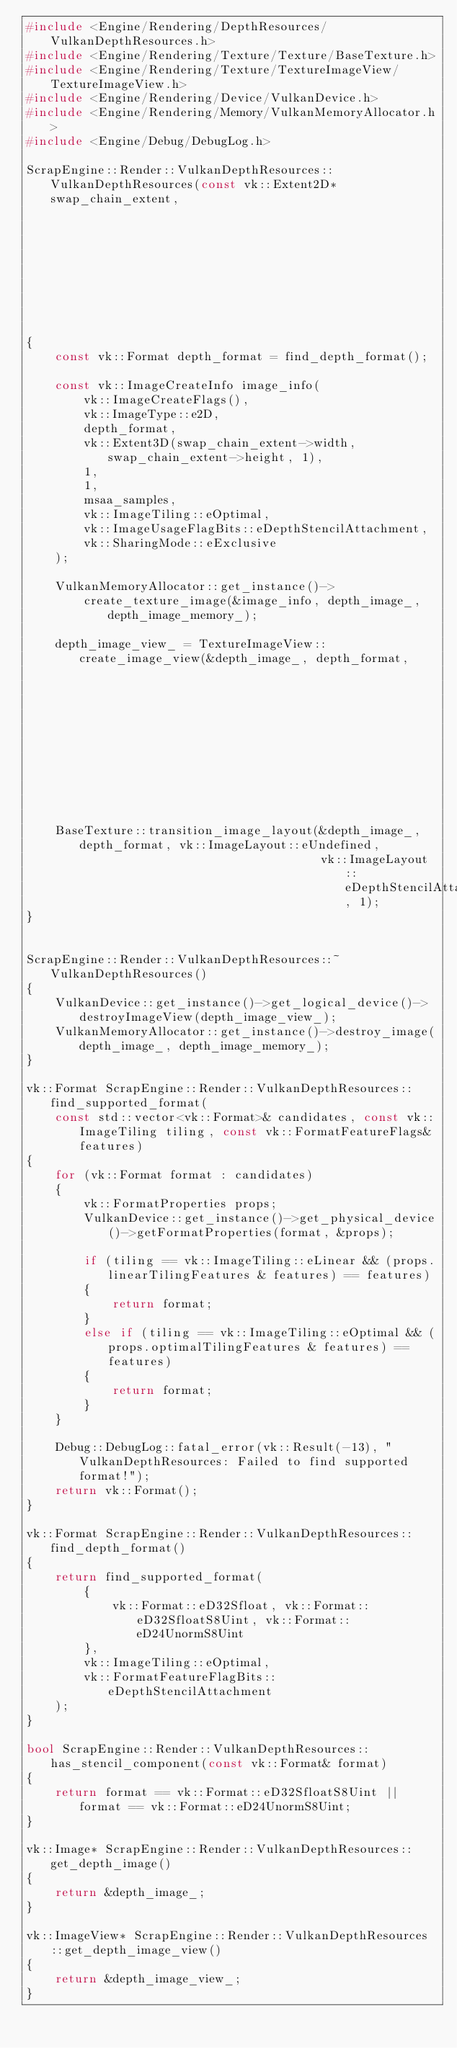Convert code to text. <code><loc_0><loc_0><loc_500><loc_500><_C++_>#include <Engine/Rendering/DepthResources/VulkanDepthResources.h>
#include <Engine/Rendering/Texture/Texture/BaseTexture.h>
#include <Engine/Rendering/Texture/TextureImageView/TextureImageView.h>
#include <Engine/Rendering/Device/VulkanDevice.h>
#include <Engine/Rendering/Memory/VulkanMemoryAllocator.h>
#include <Engine/Debug/DebugLog.h>

ScrapEngine::Render::VulkanDepthResources::VulkanDepthResources(const vk::Extent2D* swap_chain_extent,
                                                                const vk::SampleCountFlagBits msaa_samples)
{
	const vk::Format depth_format = find_depth_format();

	const vk::ImageCreateInfo image_info(
		vk::ImageCreateFlags(),
		vk::ImageType::e2D,
		depth_format,
		vk::Extent3D(swap_chain_extent->width, swap_chain_extent->height, 1),
		1,
		1,
		msaa_samples,
		vk::ImageTiling::eOptimal,
		vk::ImageUsageFlagBits::eDepthStencilAttachment,
		vk::SharingMode::eExclusive
	);

	VulkanMemoryAllocator::get_instance()->
		create_texture_image(&image_info, depth_image_, depth_image_memory_);

	depth_image_view_ = TextureImageView::create_image_view(&depth_image_, depth_format,
	                                                        vk::ImageAspectFlagBits::eDepth,
	                                                        1);

	BaseTexture::transition_image_layout(&depth_image_, depth_format, vk::ImageLayout::eUndefined,
	                                     vk::ImageLayout::eDepthStencilAttachmentOptimal, 1);
}


ScrapEngine::Render::VulkanDepthResources::~VulkanDepthResources()
{
	VulkanDevice::get_instance()->get_logical_device()->destroyImageView(depth_image_view_);
	VulkanMemoryAllocator::get_instance()->destroy_image(depth_image_, depth_image_memory_);
}

vk::Format ScrapEngine::Render::VulkanDepthResources::find_supported_format(
	const std::vector<vk::Format>& candidates, const vk::ImageTiling tiling, const vk::FormatFeatureFlags& features)
{
	for (vk::Format format : candidates)
	{
		vk::FormatProperties props;
		VulkanDevice::get_instance()->get_physical_device()->getFormatProperties(format, &props);

		if (tiling == vk::ImageTiling::eLinear && (props.linearTilingFeatures & features) == features)
		{
			return format;
		}
		else if (tiling == vk::ImageTiling::eOptimal && (props.optimalTilingFeatures & features) == features)
		{
			return format;
		}
	}

	Debug::DebugLog::fatal_error(vk::Result(-13), "VulkanDepthResources: Failed to find supported format!");
	return vk::Format();
}

vk::Format ScrapEngine::Render::VulkanDepthResources::find_depth_format()
{
	return find_supported_format(
		{
			vk::Format::eD32Sfloat, vk::Format::eD32SfloatS8Uint, vk::Format::eD24UnormS8Uint
		},
		vk::ImageTiling::eOptimal,
		vk::FormatFeatureFlagBits::eDepthStencilAttachment
	);
}

bool ScrapEngine::Render::VulkanDepthResources::has_stencil_component(const vk::Format& format)
{
	return format == vk::Format::eD32SfloatS8Uint || format == vk::Format::eD24UnormS8Uint;
}

vk::Image* ScrapEngine::Render::VulkanDepthResources::get_depth_image()
{
	return &depth_image_;
}

vk::ImageView* ScrapEngine::Render::VulkanDepthResources::get_depth_image_view()
{
	return &depth_image_view_;
}
</code> 